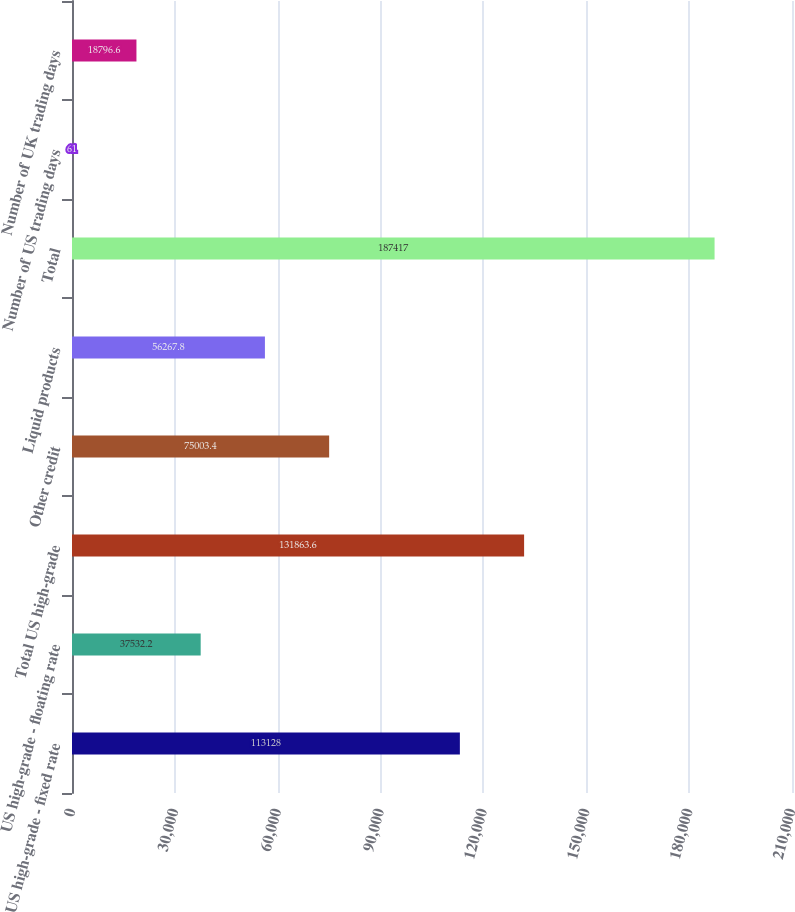<chart> <loc_0><loc_0><loc_500><loc_500><bar_chart><fcel>US high-grade - fixed rate<fcel>US high-grade - floating rate<fcel>Total US high-grade<fcel>Other credit<fcel>Liquid products<fcel>Total<fcel>Number of US trading days<fcel>Number of UK trading days<nl><fcel>113128<fcel>37532.2<fcel>131864<fcel>75003.4<fcel>56267.8<fcel>187417<fcel>61<fcel>18796.6<nl></chart> 